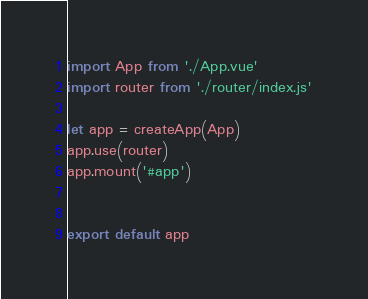Convert code to text. <code><loc_0><loc_0><loc_500><loc_500><_JavaScript_>import App from './App.vue'
import router from './router/index.js'

let app = createApp(App)
app.use(router)
app.mount('#app')


export default app
</code> 